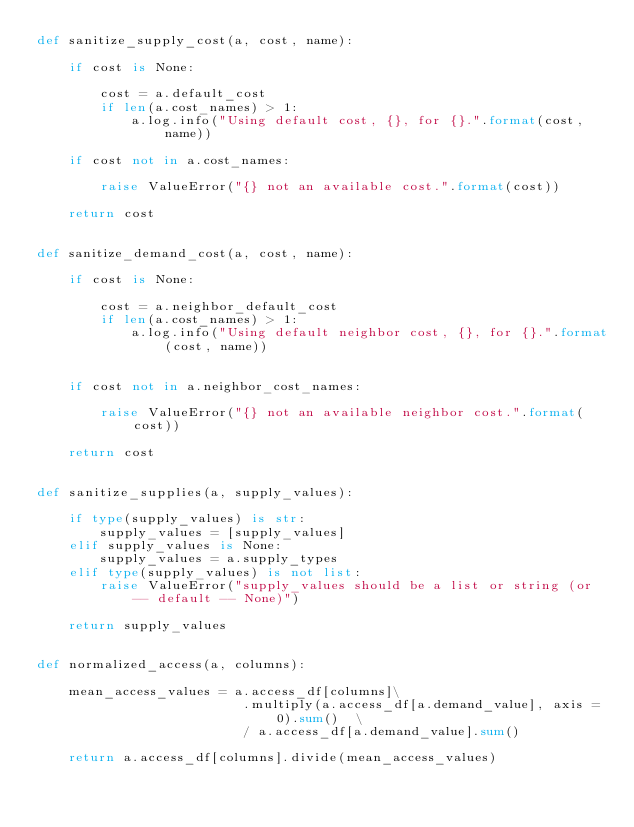<code> <loc_0><loc_0><loc_500><loc_500><_Python_>def sanitize_supply_cost(a, cost, name):

    if cost is None:

        cost = a.default_cost
        if len(a.cost_names) > 1:
            a.log.info("Using default cost, {}, for {}.".format(cost, name))

    if cost not in a.cost_names:

        raise ValueError("{} not an available cost.".format(cost))

    return cost


def sanitize_demand_cost(a, cost, name):

    if cost is None:

        cost = a.neighbor_default_cost
        if len(a.cost_names) > 1:
            a.log.info("Using default neighbor cost, {}, for {}.".format(cost, name))


    if cost not in a.neighbor_cost_names:

        raise ValueError("{} not an available neighbor cost.".format(cost))

    return cost


def sanitize_supplies(a, supply_values):

    if type(supply_values) is str:
        supply_values = [supply_values]
    elif supply_values is None:
        supply_values = a.supply_types
    elif type(supply_values) is not list:
        raise ValueError("supply_values should be a list or string (or -- default -- None)")

    return supply_values


def normalized_access(a, columns):

    mean_access_values = a.access_df[columns]\
                          .multiply(a.access_df[a.demand_value], axis = 0).sum()  \
                          / a.access_df[a.demand_value].sum()

    return a.access_df[columns].divide(mean_access_values)
</code> 